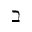<formula> <loc_0><loc_0><loc_500><loc_500>\beth</formula> 